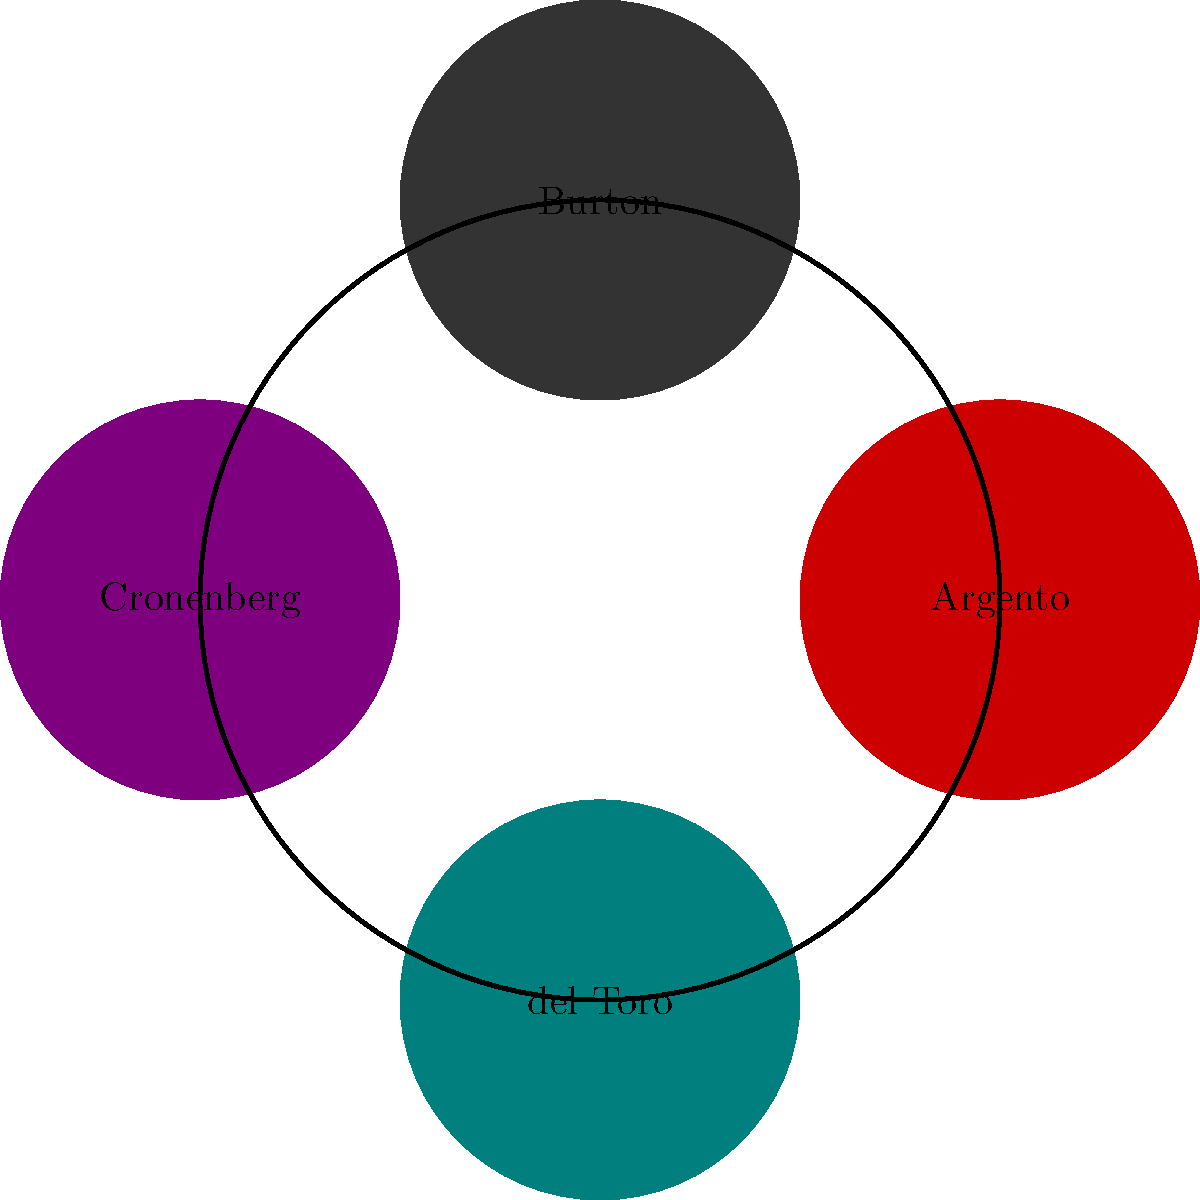Match the following horror film directors to their signature visual styles represented by the colored circles:

1. Deep reds and dramatic lighting
2. Gothic and whimsical dark fantasy
3. Body horror and organic transformations
4. Dark fairy tales with intricate creature designs

Which color corresponds to each director's style? To answer this question, we need to analyze each director's signature style and match it to the given descriptions:

1. Dario Argento is known for his use of deep reds and dramatic lighting in films like "Suspiria". This corresponds to the red circle.

2. Tim Burton's style is characterized by gothic and whimsical dark fantasy, as seen in "Sleepy Hollow" and "Corpse Bride". This matches the dark grey circle.

3. David Cronenberg is famous for his body horror and organic transformations in films like "The Fly" and "Videodrome". This aligns with the purple circle.

4. Guillermo del Toro creates dark fairy tales with intricate creature designs, as seen in "Pan's Labyrinth" and "The Shape of Water". This fits the teal circle.

By matching these styles to the colors and director names in the diagram, we can determine the correct correspondences.
Answer: Argento: Red, Burton: Dark grey, Cronenberg: Purple, del Toro: Teal 